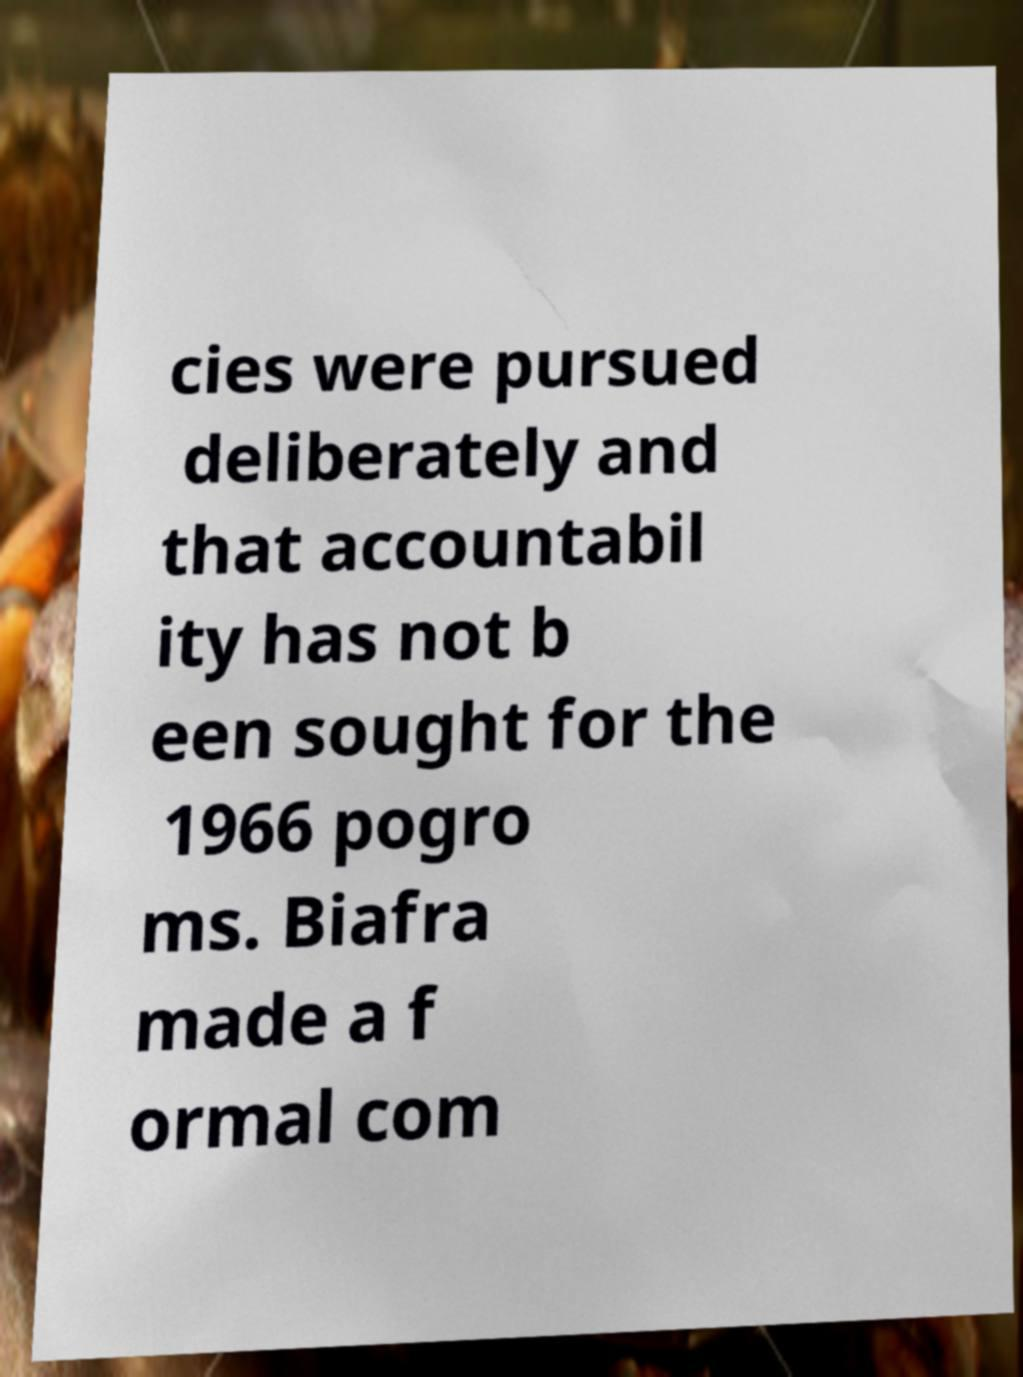Can you accurately transcribe the text from the provided image for me? cies were pursued deliberately and that accountabil ity has not b een sought for the 1966 pogro ms. Biafra made a f ormal com 